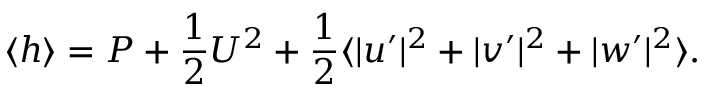<formula> <loc_0><loc_0><loc_500><loc_500>\langle h \rangle = P + \frac { 1 } { 2 } U ^ { 2 } + \frac { 1 } { 2 } \langle | u ^ { \prime } | ^ { 2 } + | v ^ { \prime } | ^ { 2 } + | w ^ { \prime } | ^ { 2 } \rangle .</formula> 